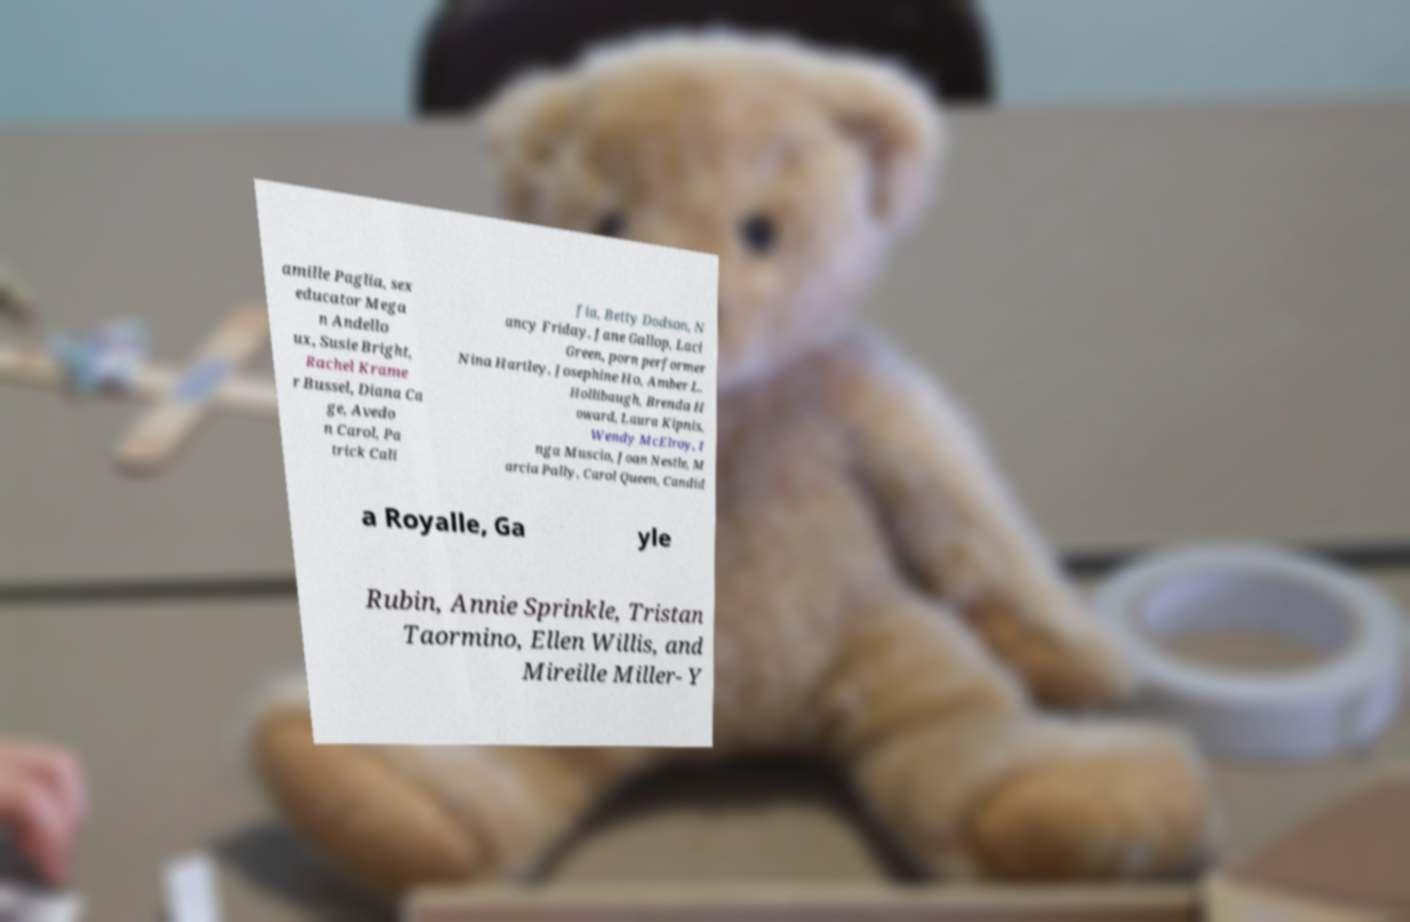Could you assist in decoding the text presented in this image and type it out clearly? amille Paglia, sex educator Mega n Andello ux, Susie Bright, Rachel Krame r Bussel, Diana Ca ge, Avedo n Carol, Pa trick Cali fia, Betty Dodson, N ancy Friday, Jane Gallop, Laci Green, porn performer Nina Hartley, Josephine Ho, Amber L. Hollibaugh, Brenda H oward, Laura Kipnis, Wendy McElroy, I nga Muscio, Joan Nestle, M arcia Pally, Carol Queen, Candid a Royalle, Ga yle Rubin, Annie Sprinkle, Tristan Taormino, Ellen Willis, and Mireille Miller- Y 